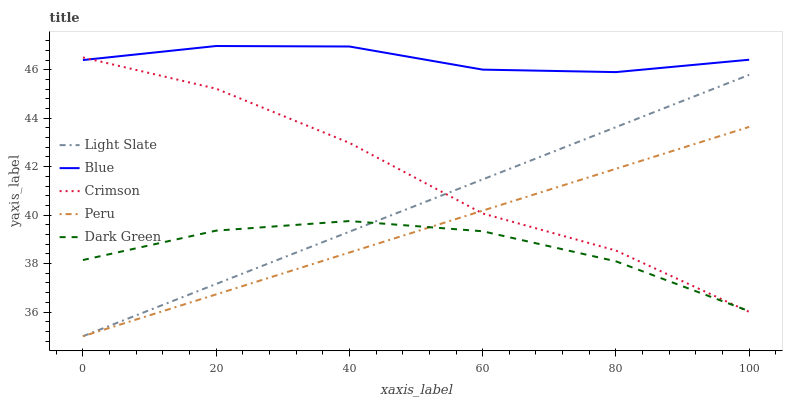Does Dark Green have the minimum area under the curve?
Answer yes or no. Yes. Does Blue have the maximum area under the curve?
Answer yes or no. Yes. Does Peru have the minimum area under the curve?
Answer yes or no. No. Does Peru have the maximum area under the curve?
Answer yes or no. No. Is Peru the smoothest?
Answer yes or no. Yes. Is Crimson the roughest?
Answer yes or no. Yes. Is Blue the smoothest?
Answer yes or no. No. Is Blue the roughest?
Answer yes or no. No. Does Light Slate have the lowest value?
Answer yes or no. Yes. Does Blue have the lowest value?
Answer yes or no. No. Does Blue have the highest value?
Answer yes or no. Yes. Does Peru have the highest value?
Answer yes or no. No. Is Light Slate less than Blue?
Answer yes or no. Yes. Is Blue greater than Light Slate?
Answer yes or no. Yes. Does Peru intersect Crimson?
Answer yes or no. Yes. Is Peru less than Crimson?
Answer yes or no. No. Is Peru greater than Crimson?
Answer yes or no. No. Does Light Slate intersect Blue?
Answer yes or no. No. 